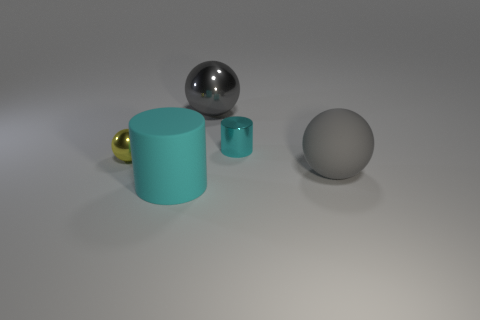How many objects are there in total, and can you describe their shapes? There are five objects in total, including a large teal cylinder, a small teal cup, a gold sphere, a silver sphere, and a matte gray sphere. Which object seems to be the largest? The largest object appears to be the large teal cylinder due to its height and volume. 